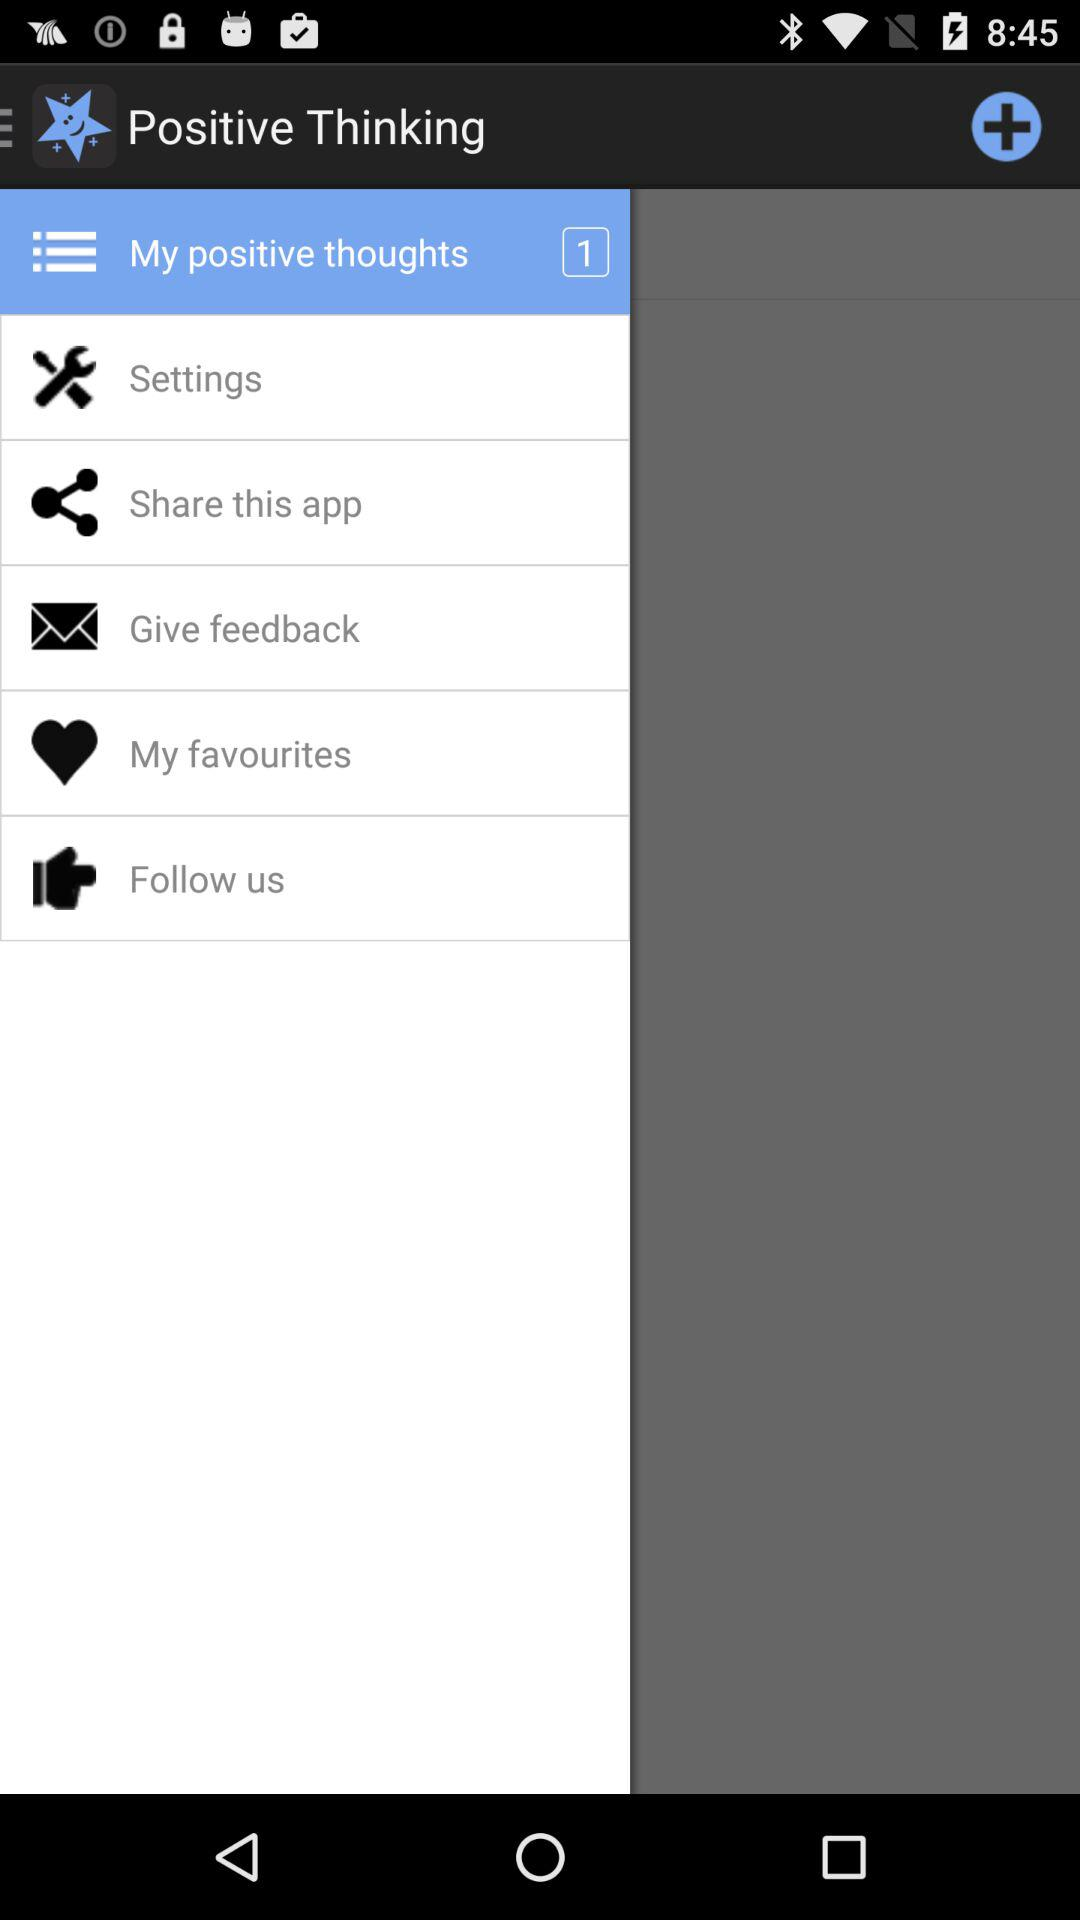How many notifications are pending in "My positive thoughts"? The number of notifications that are pending in "My positive thoughts" is 1. 